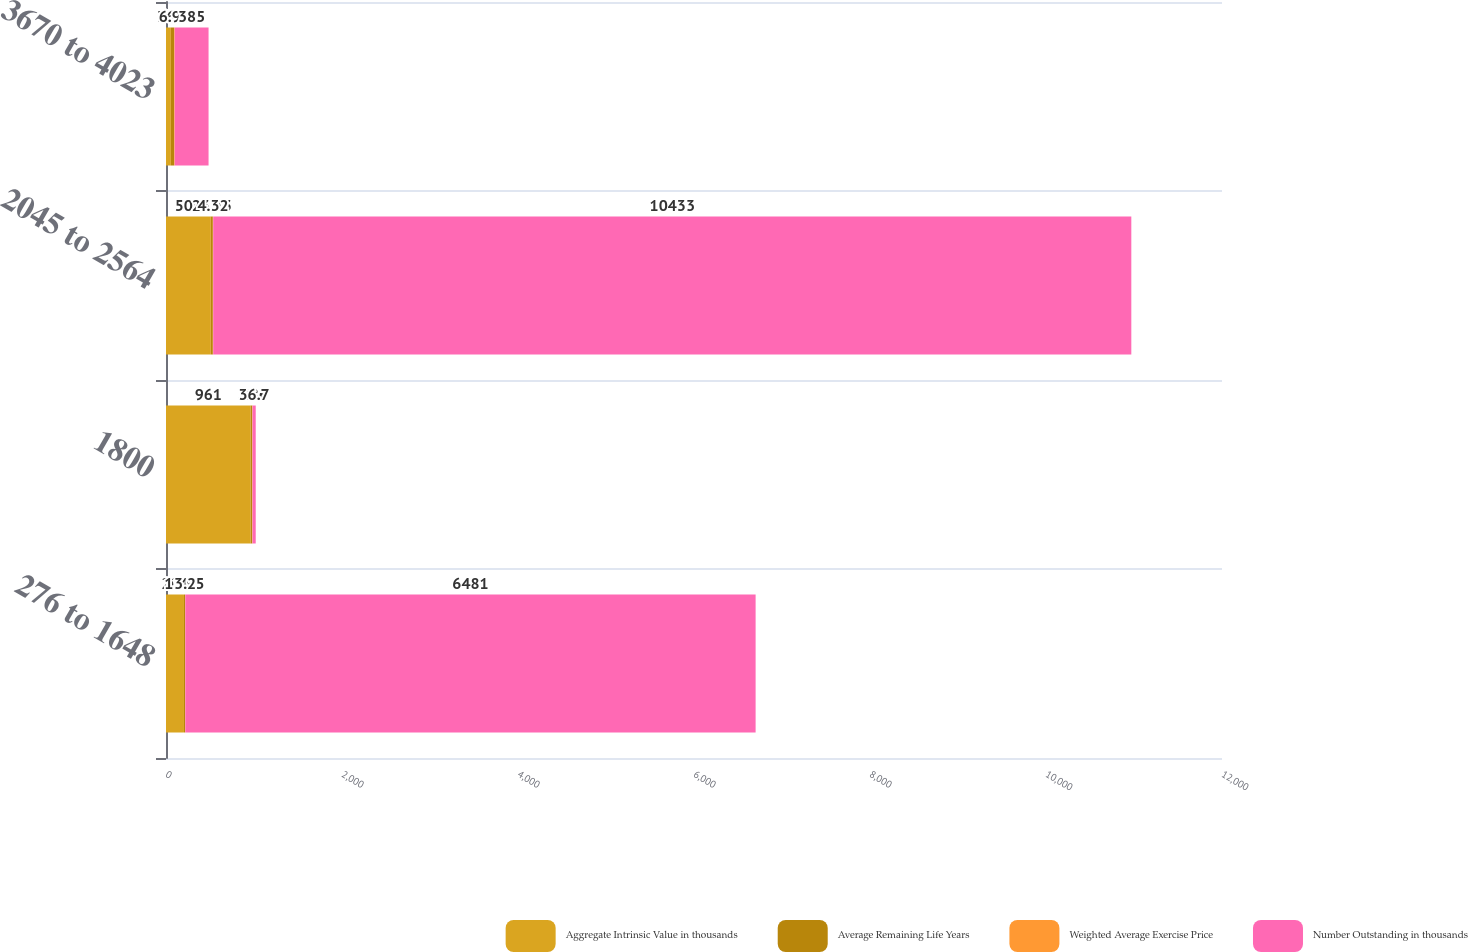<chart> <loc_0><loc_0><loc_500><loc_500><stacked_bar_chart><ecel><fcel>276 to 1648<fcel>1800<fcel>2045 to 2564<fcel>3670 to 4023<nl><fcel>Aggregate Intrinsic Value in thousands<fcel>204<fcel>961<fcel>509<fcel>55<nl><fcel>Average Remaining Life Years<fcel>11.95<fcel>18<fcel>23.23<fcel>36.7<nl><fcel>Weighted Average Exercise Price<fcel>3.2<fcel>3.86<fcel>4.32<fcel>6.95<nl><fcel>Number Outstanding in thousands<fcel>6481<fcel>36.7<fcel>10433<fcel>385<nl></chart> 